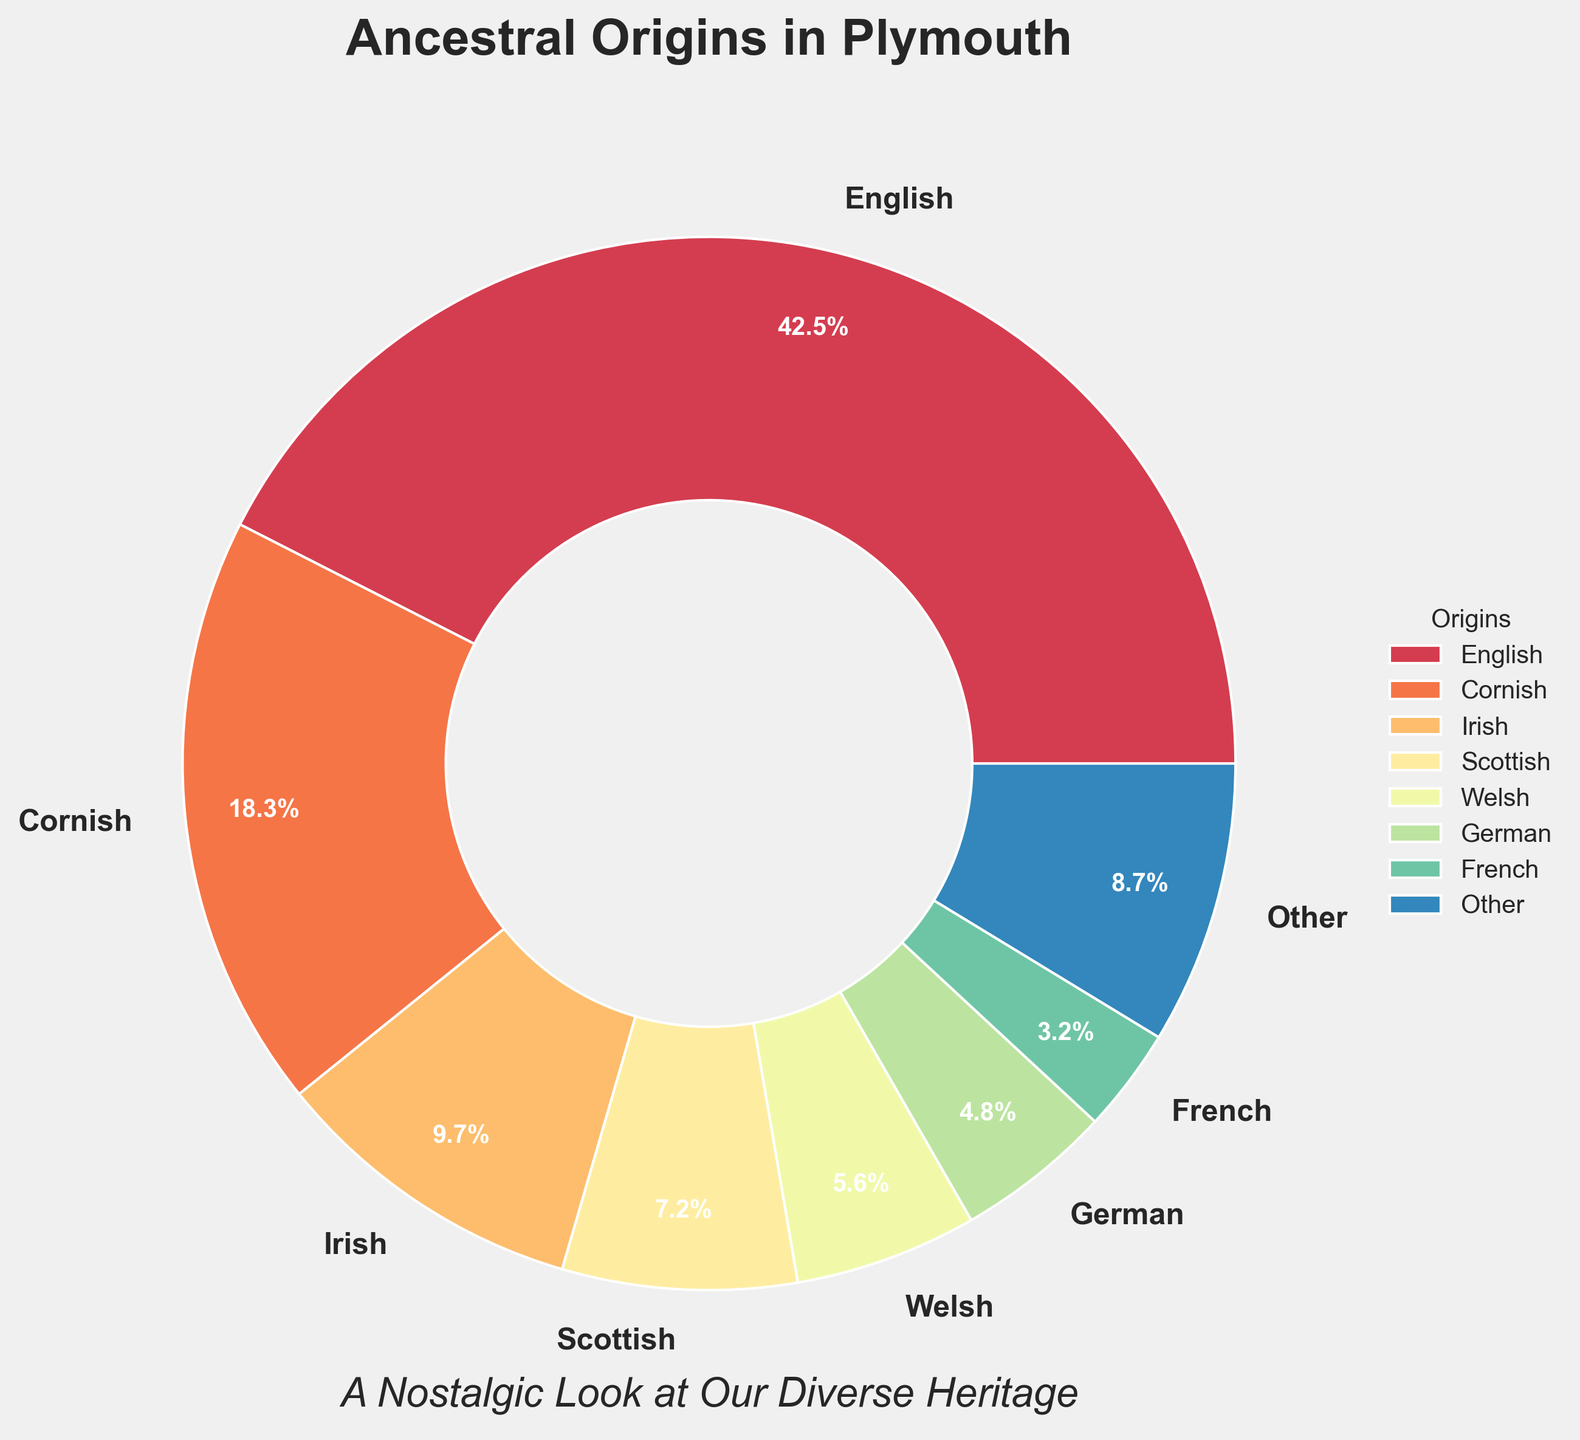What is the most common ancestral origin in Plymouth? The pie chart shows different ancestral origins and their corresponding percentages. The largest wedge, marked with "English," has the highest percentage at 42.5%.
Answer: English What percentage of the population has Cornish ancestry? The pie chart labels each wedge with both the name of the ancestral origin and its percentage. The wedge labeled "Cornish" shows a percentage of 18.3%.
Answer: 18.3% What are the combined percentages of Welsh and German ancestral origins? To find the combined percentage, add the individual percentages of Welsh (5.6%) and German (4.8%). 5.6 + 4.8 = 10.4%.
Answer: 10.4% Which ancestral origin represents 9.7% of Plymouth's population? The pie chart shows that the wedge with a percentage of 9.7% is labeled "Irish."
Answer: Irish How many ancestral origins have a percentage lower than 5%? To answer this, count the wedges labeled with percentages less than 5%. German (4.8%), French (3.2%), Dutch (2.5%), Polish (1.9%), Italian (1.6%), Norman (1.4%), and Scandinavian (1.3%), total 7 origins.
Answer: 7 What is the total percentage of population that falls under the "Other" category? The "Other" category aggregates the percentages of all origins lower than the threshold. The chart's legend or labels show this percentage directly (not given explicitly in the question).
Answer: X (from figure) What is the difference in percentage between English and Cornish ancestries? Subtract the Cornish percentage (18.3%) from the English percentage (42.5%). 42.5 - 18.3 = 24.2%.
Answer: 24.2% Which two ancestral origins have the smallest percentages, and what are they? Look for the two smallest wedges in the pie chart. The chart labels "Norman" at 1.4% and "Scandinavian" at 1.3%.
Answer: Norman and Scandinavian How does the Scottish ancestry percentage compare to the German ancestry percentage? The pie chart shows that Scottish ancestry has a percentage of 7.2%, and German ancestry has a percentage of 4.8%. 7.2% is greater than 4.8%.
Answer: Scottish greater than German What is the percentage range of the ancestral origins that are under 10% but above 5%? Identify the wedges with percentages under 10% and above 5%. They are Irish (9.7%), Scottish (7.2%), and Welsh (5.6%).
Answer: 5.6% to 9.7% 